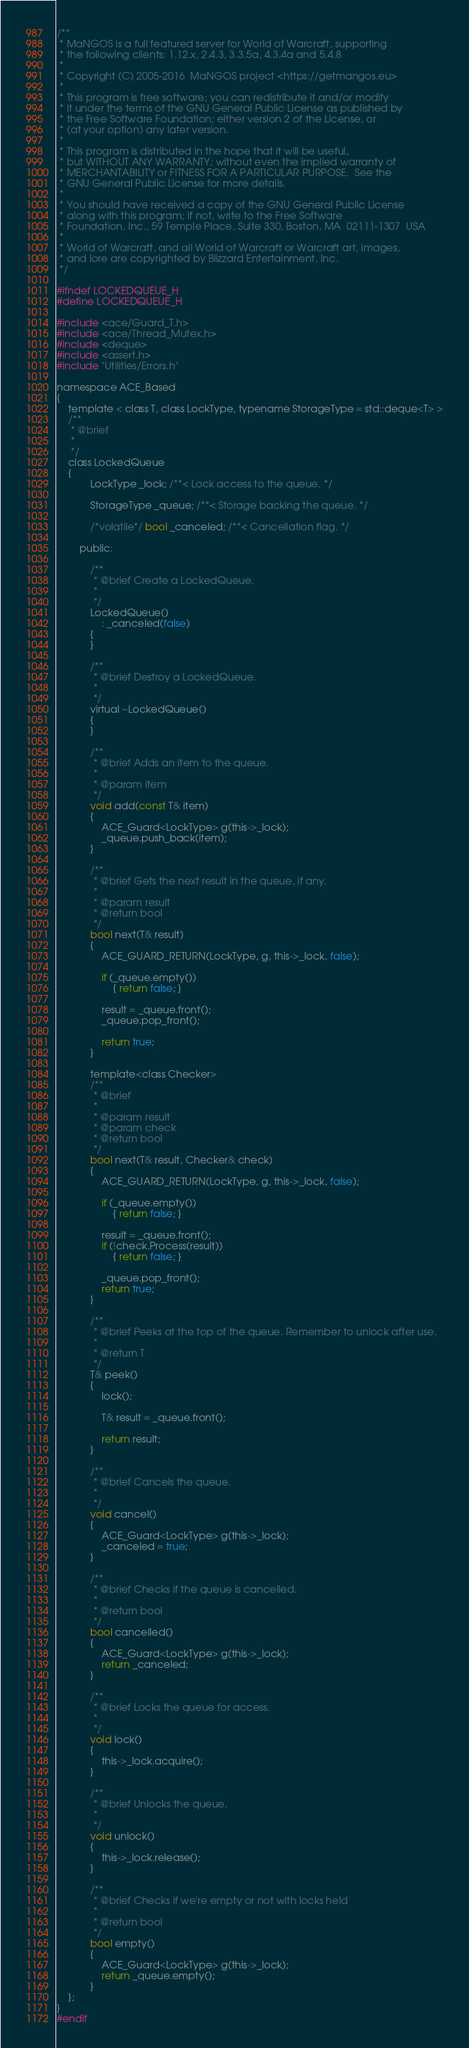<code> <loc_0><loc_0><loc_500><loc_500><_C_>/**
 * MaNGOS is a full featured server for World of Warcraft, supporting
 * the following clients: 1.12.x, 2.4.3, 3.3.5a, 4.3.4a and 5.4.8
 *
 * Copyright (C) 2005-2016  MaNGOS project <https://getmangos.eu>
 *
 * This program is free software; you can redistribute it and/or modify
 * it under the terms of the GNU General Public License as published by
 * the Free Software Foundation; either version 2 of the License, or
 * (at your option) any later version.
 *
 * This program is distributed in the hope that it will be useful,
 * but WITHOUT ANY WARRANTY; without even the implied warranty of
 * MERCHANTABILITY or FITNESS FOR A PARTICULAR PURPOSE.  See the
 * GNU General Public License for more details.
 *
 * You should have received a copy of the GNU General Public License
 * along with this program; if not, write to the Free Software
 * Foundation, Inc., 59 Temple Place, Suite 330, Boston, MA  02111-1307  USA
 *
 * World of Warcraft, and all World of Warcraft or Warcraft art, images,
 * and lore are copyrighted by Blizzard Entertainment, Inc.
 */

#ifndef LOCKEDQUEUE_H
#define LOCKEDQUEUE_H

#include <ace/Guard_T.h>
#include <ace/Thread_Mutex.h>
#include <deque>
#include <assert.h>
#include "Utilities/Errors.h"

namespace ACE_Based
{
    template < class T, class LockType, typename StorageType = std::deque<T> >
    /**
     * @brief
     *
     */
    class LockedQueue
    {
            LockType _lock; /**< Lock access to the queue. */

            StorageType _queue; /**< Storage backing the queue. */

            /*volatile*/ bool _canceled; /**< Cancellation flag. */

        public:

            /**
             * @brief Create a LockedQueue.
             *
             */
            LockedQueue()
                : _canceled(false)
            {
            }

            /**
             * @brief Destroy a LockedQueue.
             *
             */
            virtual ~LockedQueue()
            {
            }

            /**
             * @brief Adds an item to the queue.
             *
             * @param item
             */
            void add(const T& item)
            {
                ACE_Guard<LockType> g(this->_lock);
                _queue.push_back(item);
            }

            /**
             * @brief Gets the next result in the queue, if any.
             *
             * @param result
             * @return bool
             */
            bool next(T& result)
            {
                ACE_GUARD_RETURN(LockType, g, this->_lock, false);

                if (_queue.empty())
                    { return false; }

                result = _queue.front();
                _queue.pop_front();

                return true;
            }

            template<class Checker>
            /**
             * @brief
             *
             * @param result
             * @param check
             * @return bool
             */
            bool next(T& result, Checker& check)
            {
                ACE_GUARD_RETURN(LockType, g, this->_lock, false);

                if (_queue.empty())
                    { return false; }

                result = _queue.front();
                if (!check.Process(result))
                    { return false; }

                _queue.pop_front();
                return true;
            }

            /**
             * @brief Peeks at the top of the queue. Remember to unlock after use.
             *
             * @return T
             */
            T& peek()
            {
                lock();

                T& result = _queue.front();

                return result;
            }

            /**
             * @brief Cancels the queue.
             *
             */
            void cancel()
            {
                ACE_Guard<LockType> g(this->_lock);
                _canceled = true;
            }

            /**
             * @brief Checks if the queue is cancelled.
             *
             * @return bool
             */
            bool cancelled()
            {
                ACE_Guard<LockType> g(this->_lock);
                return _canceled;
            }

            /**
             * @brief Locks the queue for access.
             *
             */
            void lock()
            {
                this->_lock.acquire();
            }

            /**
             * @brief Unlocks the queue.
             *
             */
            void unlock()
            {
                this->_lock.release();
            }

            /**
             * @brief Checks if we're empty or not with locks held
             *
             * @return bool
             */
            bool empty()
            {
                ACE_Guard<LockType> g(this->_lock);
                return _queue.empty();
            }
    };
}
#endif
</code> 